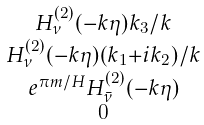<formula> <loc_0><loc_0><loc_500><loc_500>\begin{smallmatrix} H _ { \nu } ^ { ( 2 ) } ( - k \eta ) k _ { 3 } / k \\ H _ { \nu } ^ { ( 2 ) } ( - k \eta ) ( k _ { 1 } + i k _ { 2 } ) / k \\ e ^ { \pi m / H } H _ { \bar { \nu } } ^ { ( 2 ) } ( - k \eta ) \\ 0 \end{smallmatrix}</formula> 